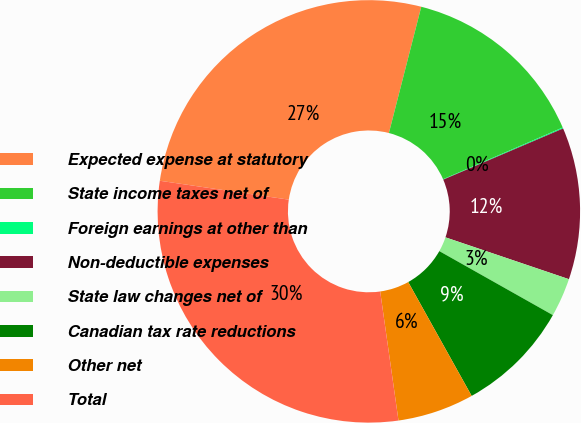Convert chart to OTSL. <chart><loc_0><loc_0><loc_500><loc_500><pie_chart><fcel>Expected expense at statutory<fcel>State income taxes net of<fcel>Foreign earnings at other than<fcel>Non-deductible expenses<fcel>State law changes net of<fcel>Canadian tax rate reductions<fcel>Other net<fcel>Total<nl><fcel>26.68%<fcel>14.51%<fcel>0.08%<fcel>11.62%<fcel>2.97%<fcel>8.74%<fcel>5.85%<fcel>29.56%<nl></chart> 